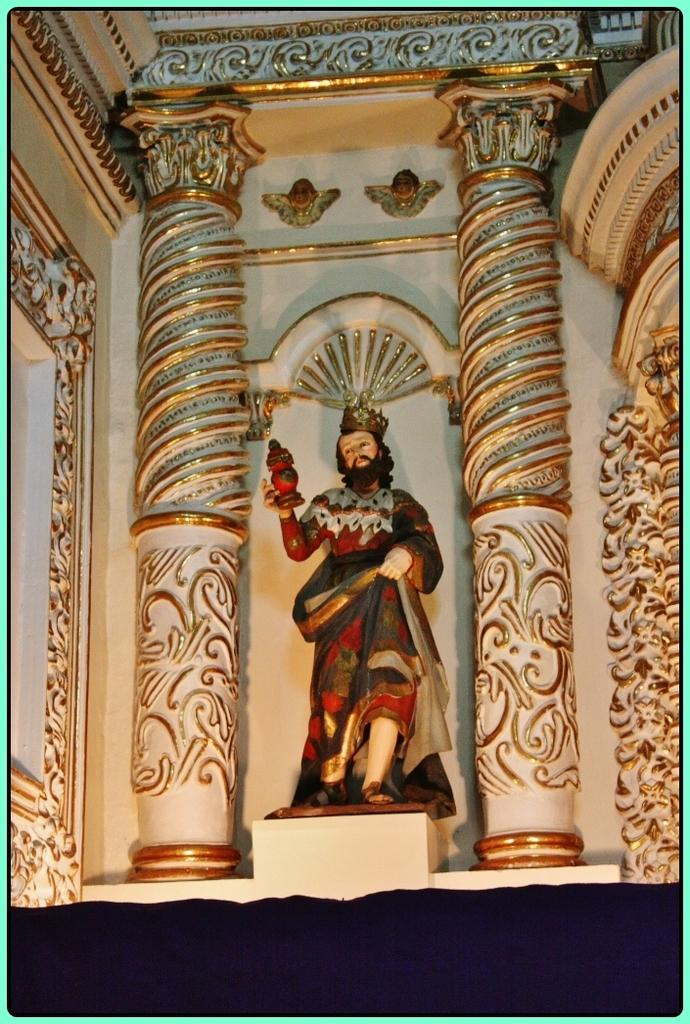What is the main structure in the center of the image? There is a building in the center of the image. What other architectural elements can be seen in the image? There is a wall and pillars in the image. What covers the top of the building? There is a roof in the image. Are there any human-like figures in the image? Yes, there is a human statue in the image. How many dolls are sitting on the roof of the building in the image? There are no dolls present in the image; it only features a building, wall, pillars, roof, and a human statue. 